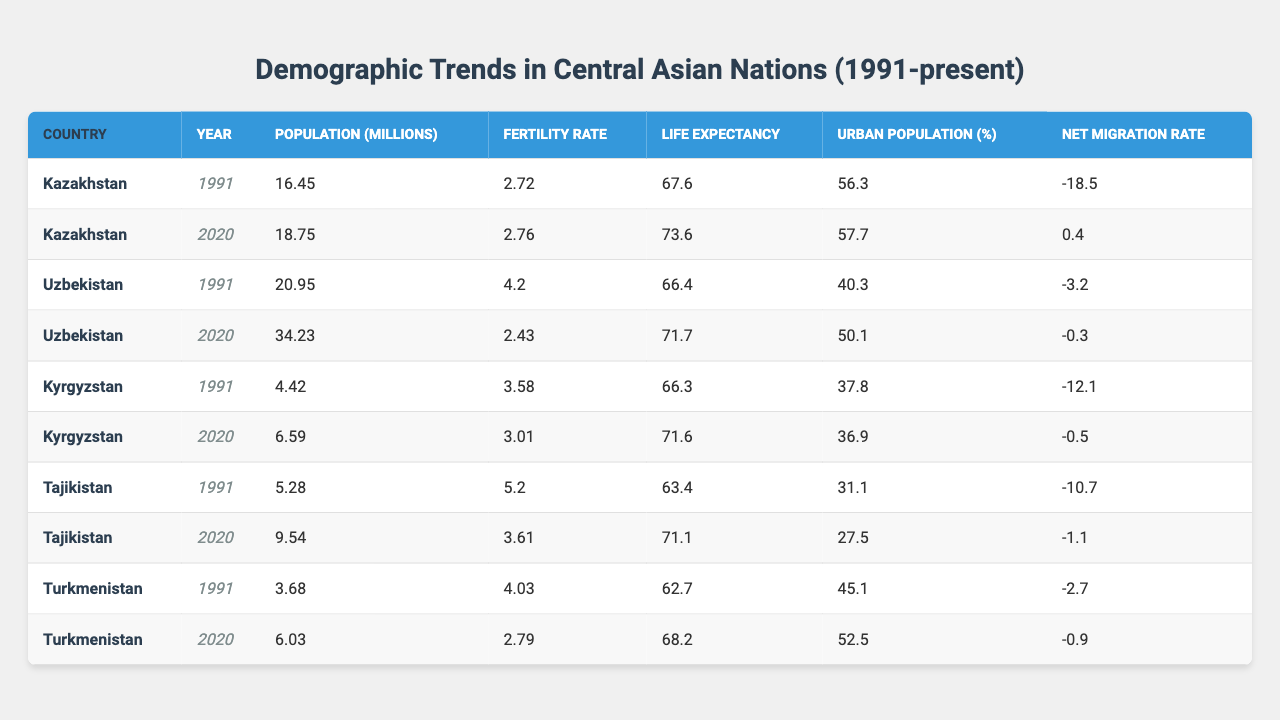What was the population of Uzbekistan in 1991? In the table, under Uzbekistan for the year 1991, the population recorded is 20.95 million.
Answer: 20.95 million What is the fertility rate of Kyrgyzstan in 2020? Referring to the table, Kyrgyzstan in 2020 has a fertility rate of 3.01.
Answer: 3.01 Which country had the highest fertility rate in 1991? By comparing the fertility rates in 1991, Tajikistan has the highest rate of 5.20.
Answer: Tajikistan What was the life expectancy in Kazakhstan from 1991 to 2020? In 1991, the life expectancy was 67.6, which increased to 73.6 in 2020, reflecting a growth of 6 years.
Answer: 6 years Is the net migration rate for Turkmenistan positive or negative in 2020? The net migration rate for Turkmenistan in 2020 is -0.9, which indicates a negative migration trend.
Answer: Negative What was the change in urban population percentage for Tajikistan from 1991 to 2020? The urban population in Tajikistan decreased from 31.1% in 1991 to 27.5% in 2020, which is a decline of 3.6 percentage points.
Answer: 3.6 percentage points Which country experienced an increase in both population and life expectancy from 1991 to 2020? Observing the data, both Kazakhstan and Uzbekistan experienced an increase in population and life expectancy from 1991 to 2020.
Answer: Kazakhstan and Uzbekistan What is the average population of Central Asian nations in 2020? Summing the populations for 2020 (18.75 + 34.23 + 6.59 + 9.54 + 6.03) gives 75.14 million, which divided by 5 results in an average of 15.028 million.
Answer: 15.028 million Did the fertility rate decrease across all Central Asian countries from 1991 to 2020? By evaluating the fertility rates, Uzbekistan and Tajikistan show a decrease, while Kyrgyzstan’s rate decreased but at a slower rate. Therefore, it did not decrease in all countries.
Answer: No What was the urban population percentage in Uzbekistan in 2020 compared to 1991? The urban population increased from 40.3% in 1991 to 50.1% in 2020, indicating a rise of 9.8 percentage points.
Answer: 9.8 percentage points 